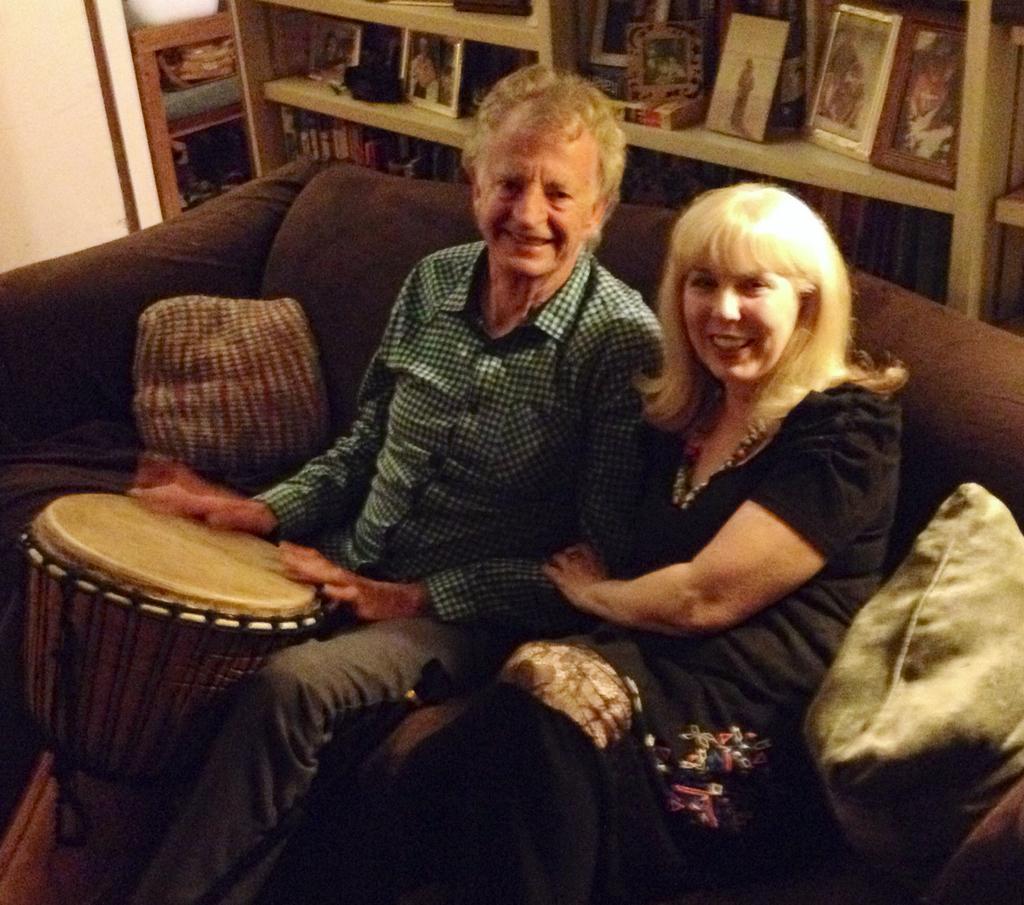Describe this image in one or two sentences. In this image I can see a woman in black dress and a man wearing a green shirt and a pant sitting on the couch, I can see two cushions on the couch and the man is holding a musical instrument. In the background I can see the wall and the shelf in which there are few photo frames and few books. 